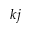<formula> <loc_0><loc_0><loc_500><loc_500>k j</formula> 